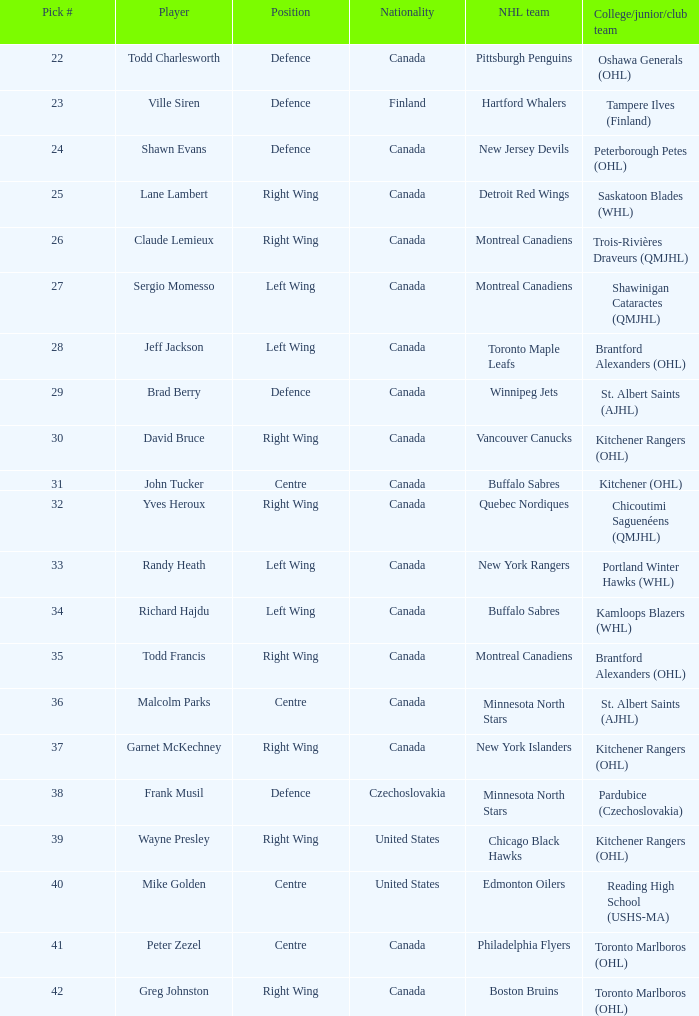What is the selection number when the nhl team is montreal canadiens and the college/junior/club team is trois-rivières draveurs (qmjhl)? 26.0. 